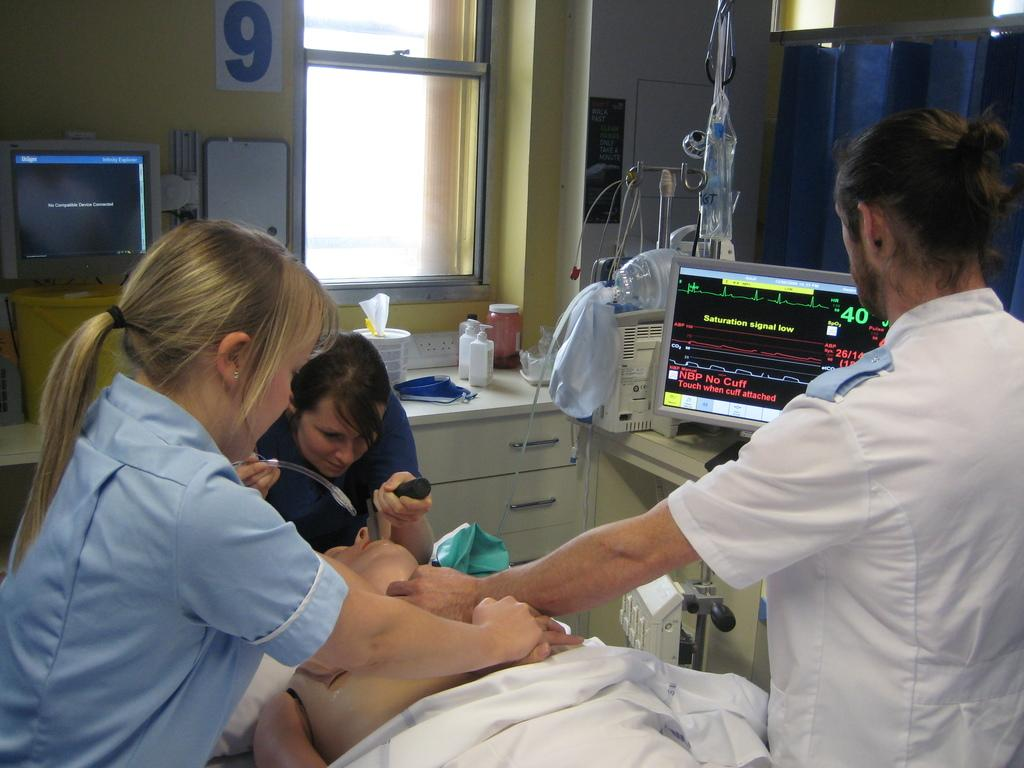Who or what is present in the image? There are people in the image. What object can be seen in the image that might be used for displaying information or media? There is a display device in the image. What architectural feature is visible in the background of the image? There is a window in the background of the image. What type of hill can be seen outside the window in the image? There is no hill visible outside the window in the image. 